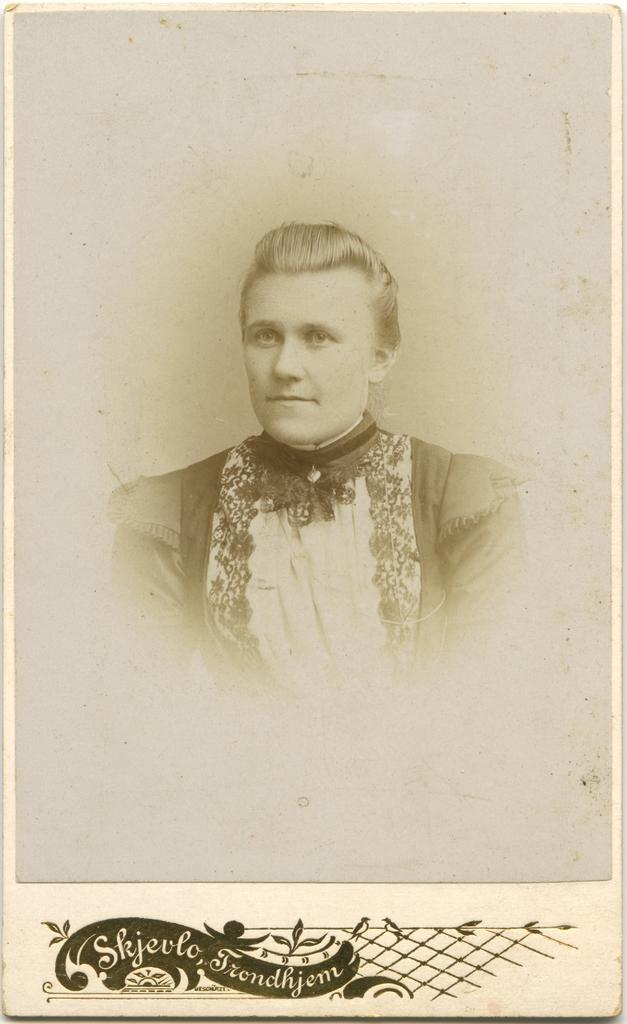What is the main subject of the image? There is a photograph of a man in the image. What else can be seen in the image besides the man? There is a design at the bottom of the image. Can you describe the design at the bottom of the image? The design has writing on it. What type of engine is depicted in the image? There is no engine present in the image; it features a photograph of a man and a design with writing. How many sneezes can be heard in the image? There are no sounds, including sneezes, present in the image. 